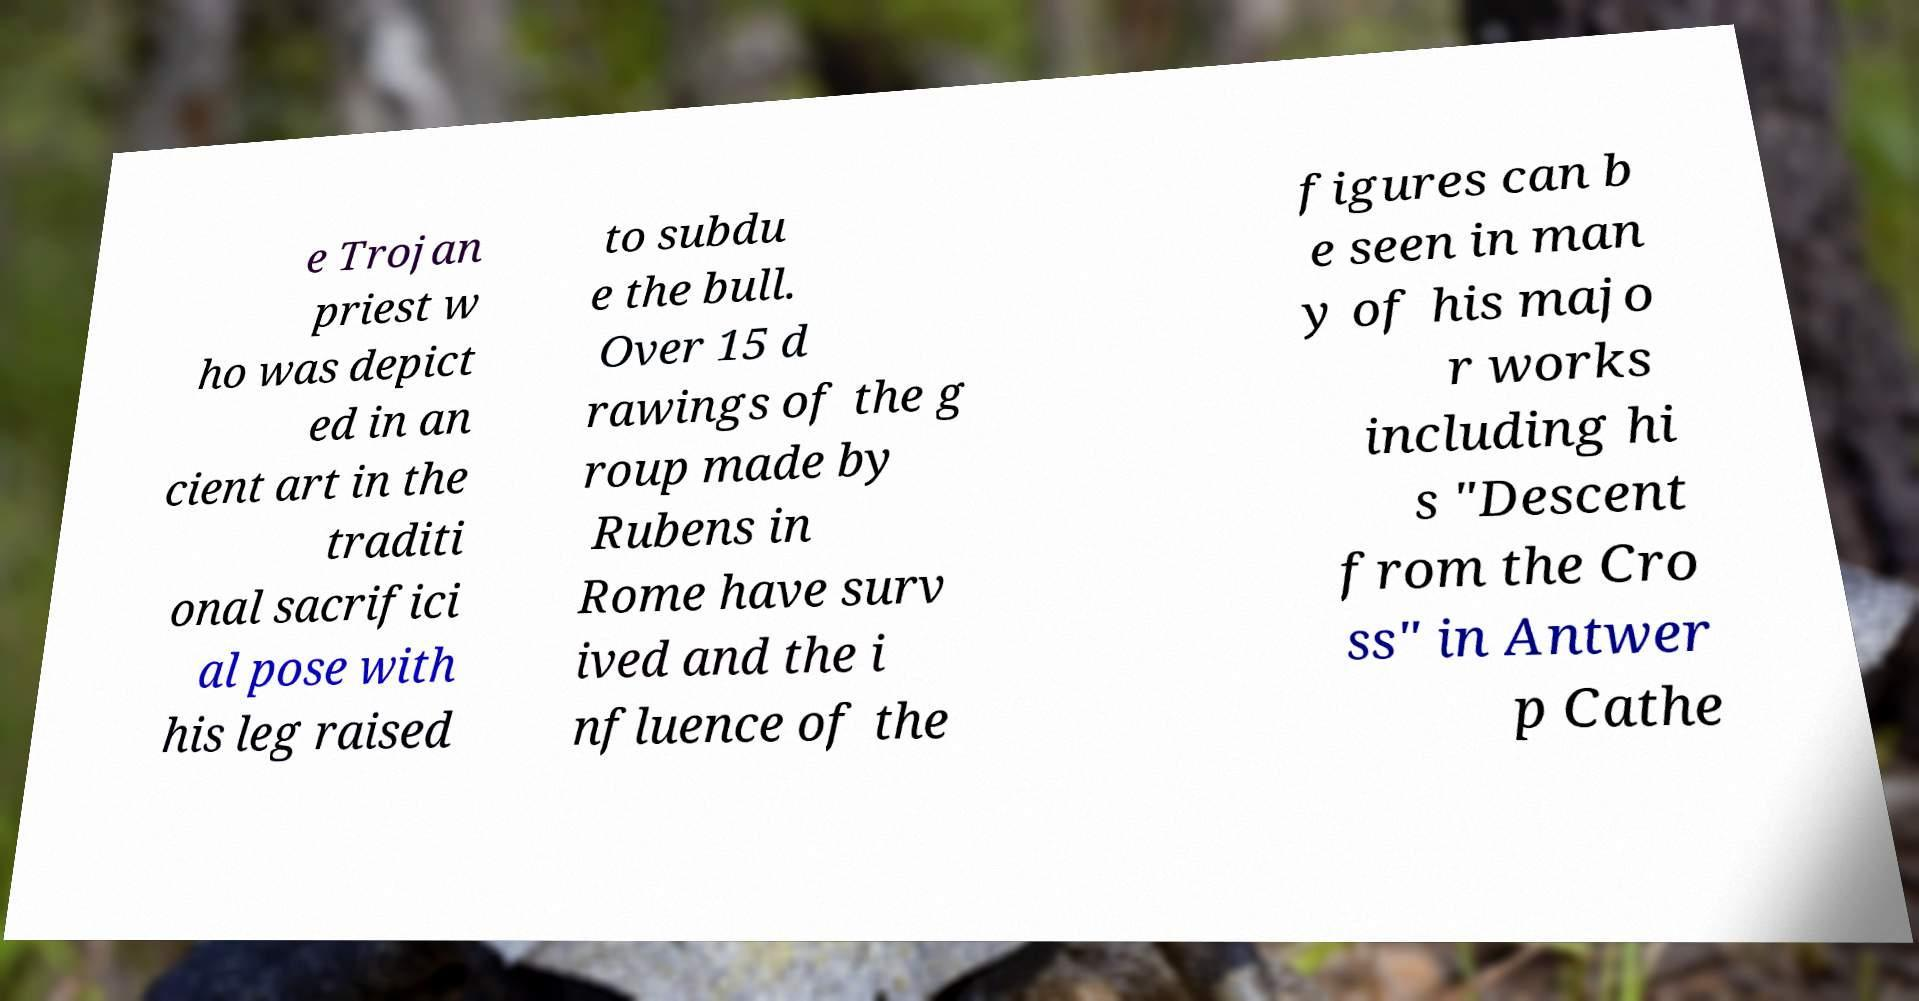Could you extract and type out the text from this image? e Trojan priest w ho was depict ed in an cient art in the traditi onal sacrifici al pose with his leg raised to subdu e the bull. Over 15 d rawings of the g roup made by Rubens in Rome have surv ived and the i nfluence of the figures can b e seen in man y of his majo r works including hi s "Descent from the Cro ss" in Antwer p Cathe 